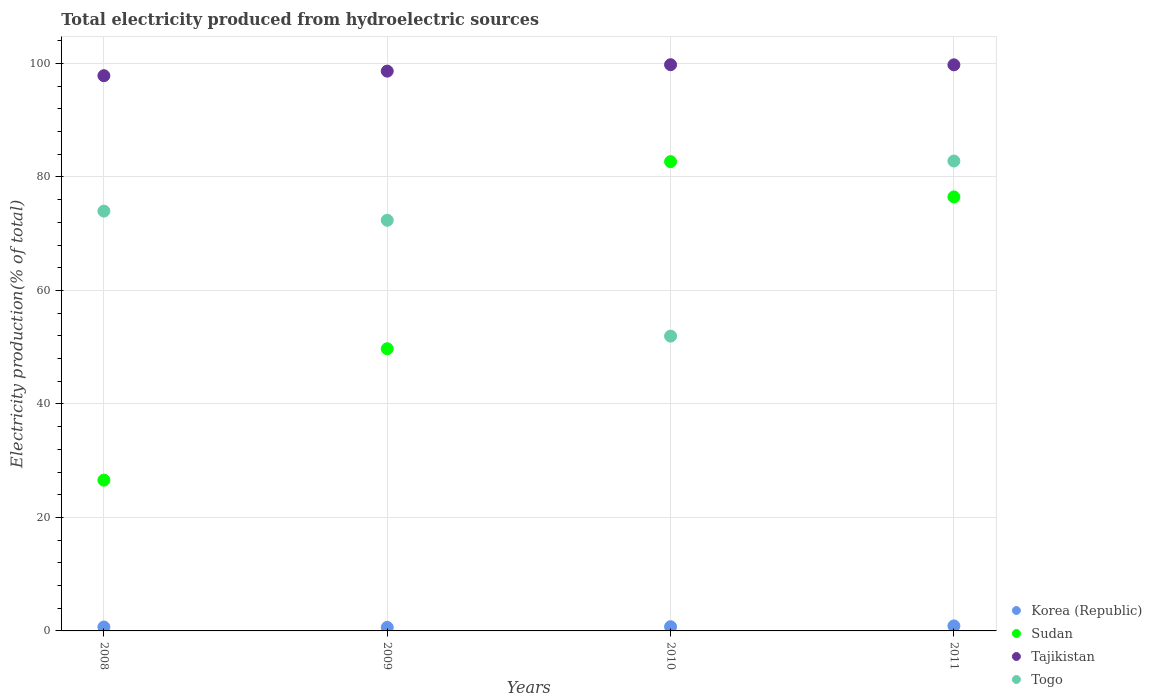What is the total electricity produced in Tajikistan in 2009?
Keep it short and to the point. 98.65. Across all years, what is the maximum total electricity produced in Sudan?
Offer a very short reply. 82.7. Across all years, what is the minimum total electricity produced in Tajikistan?
Keep it short and to the point. 97.85. In which year was the total electricity produced in Tajikistan maximum?
Provide a succinct answer. 2010. What is the total total electricity produced in Sudan in the graph?
Your answer should be very brief. 235.49. What is the difference between the total electricity produced in Togo in 2010 and that in 2011?
Ensure brevity in your answer.  -30.86. What is the difference between the total electricity produced in Korea (Republic) in 2009 and the total electricity produced in Sudan in 2010?
Offer a very short reply. -82.08. What is the average total electricity produced in Sudan per year?
Your answer should be very brief. 58.87. In the year 2011, what is the difference between the total electricity produced in Korea (Republic) and total electricity produced in Tajikistan?
Offer a very short reply. -98.88. What is the ratio of the total electricity produced in Sudan in 2008 to that in 2011?
Make the answer very short. 0.35. Is the difference between the total electricity produced in Korea (Republic) in 2008 and 2009 greater than the difference between the total electricity produced in Tajikistan in 2008 and 2009?
Provide a succinct answer. Yes. What is the difference between the highest and the second highest total electricity produced in Tajikistan?
Your answer should be compact. 0.02. What is the difference between the highest and the lowest total electricity produced in Sudan?
Offer a very short reply. 56.13. Is the sum of the total electricity produced in Korea (Republic) in 2008 and 2010 greater than the maximum total electricity produced in Sudan across all years?
Offer a terse response. No. Is it the case that in every year, the sum of the total electricity produced in Togo and total electricity produced in Sudan  is greater than the sum of total electricity produced in Korea (Republic) and total electricity produced in Tajikistan?
Your response must be concise. No. Is the total electricity produced in Korea (Republic) strictly less than the total electricity produced in Sudan over the years?
Make the answer very short. Yes. How many years are there in the graph?
Give a very brief answer. 4. Does the graph contain any zero values?
Ensure brevity in your answer.  No. Where does the legend appear in the graph?
Provide a succinct answer. Bottom right. How many legend labels are there?
Your response must be concise. 4. What is the title of the graph?
Give a very brief answer. Total electricity produced from hydroelectric sources. What is the Electricity production(% of total) in Korea (Republic) in 2008?
Offer a very short reply. 0.69. What is the Electricity production(% of total) in Sudan in 2008?
Keep it short and to the point. 26.57. What is the Electricity production(% of total) of Tajikistan in 2008?
Ensure brevity in your answer.  97.85. What is the Electricity production(% of total) in Togo in 2008?
Your answer should be compact. 73.98. What is the Electricity production(% of total) of Korea (Republic) in 2009?
Give a very brief answer. 0.62. What is the Electricity production(% of total) of Sudan in 2009?
Your answer should be compact. 49.73. What is the Electricity production(% of total) of Tajikistan in 2009?
Make the answer very short. 98.65. What is the Electricity production(% of total) in Togo in 2009?
Your response must be concise. 72.37. What is the Electricity production(% of total) in Korea (Republic) in 2010?
Your response must be concise. 0.74. What is the Electricity production(% of total) of Sudan in 2010?
Provide a short and direct response. 82.7. What is the Electricity production(% of total) in Tajikistan in 2010?
Your answer should be very brief. 99.79. What is the Electricity production(% of total) of Togo in 2010?
Keep it short and to the point. 51.96. What is the Electricity production(% of total) of Korea (Republic) in 2011?
Give a very brief answer. 0.88. What is the Electricity production(% of total) in Sudan in 2011?
Provide a succinct answer. 76.49. What is the Electricity production(% of total) of Tajikistan in 2011?
Your answer should be very brief. 99.77. What is the Electricity production(% of total) in Togo in 2011?
Provide a short and direct response. 82.81. Across all years, what is the maximum Electricity production(% of total) of Korea (Republic)?
Make the answer very short. 0.88. Across all years, what is the maximum Electricity production(% of total) of Sudan?
Keep it short and to the point. 82.7. Across all years, what is the maximum Electricity production(% of total) of Tajikistan?
Your answer should be compact. 99.79. Across all years, what is the maximum Electricity production(% of total) in Togo?
Your answer should be compact. 82.81. Across all years, what is the minimum Electricity production(% of total) in Korea (Republic)?
Ensure brevity in your answer.  0.62. Across all years, what is the minimum Electricity production(% of total) of Sudan?
Give a very brief answer. 26.57. Across all years, what is the minimum Electricity production(% of total) of Tajikistan?
Your answer should be compact. 97.85. Across all years, what is the minimum Electricity production(% of total) of Togo?
Ensure brevity in your answer.  51.96. What is the total Electricity production(% of total) of Korea (Republic) in the graph?
Your response must be concise. 2.94. What is the total Electricity production(% of total) in Sudan in the graph?
Offer a very short reply. 235.49. What is the total Electricity production(% of total) of Tajikistan in the graph?
Give a very brief answer. 396.06. What is the total Electricity production(% of total) of Togo in the graph?
Provide a succinct answer. 281.12. What is the difference between the Electricity production(% of total) in Korea (Republic) in 2008 and that in 2009?
Provide a short and direct response. 0.07. What is the difference between the Electricity production(% of total) in Sudan in 2008 and that in 2009?
Provide a short and direct response. -23.16. What is the difference between the Electricity production(% of total) in Tajikistan in 2008 and that in 2009?
Offer a very short reply. -0.8. What is the difference between the Electricity production(% of total) of Togo in 2008 and that in 2009?
Give a very brief answer. 1.62. What is the difference between the Electricity production(% of total) in Korea (Republic) in 2008 and that in 2010?
Your answer should be very brief. -0.05. What is the difference between the Electricity production(% of total) in Sudan in 2008 and that in 2010?
Keep it short and to the point. -56.13. What is the difference between the Electricity production(% of total) of Tajikistan in 2008 and that in 2010?
Offer a very short reply. -1.94. What is the difference between the Electricity production(% of total) of Togo in 2008 and that in 2010?
Your answer should be very brief. 22.03. What is the difference between the Electricity production(% of total) in Korea (Republic) in 2008 and that in 2011?
Offer a very short reply. -0.19. What is the difference between the Electricity production(% of total) of Sudan in 2008 and that in 2011?
Make the answer very short. -49.92. What is the difference between the Electricity production(% of total) of Tajikistan in 2008 and that in 2011?
Offer a terse response. -1.92. What is the difference between the Electricity production(% of total) of Togo in 2008 and that in 2011?
Keep it short and to the point. -8.83. What is the difference between the Electricity production(% of total) in Korea (Republic) in 2009 and that in 2010?
Your response must be concise. -0.12. What is the difference between the Electricity production(% of total) in Sudan in 2009 and that in 2010?
Make the answer very short. -32.97. What is the difference between the Electricity production(% of total) in Tajikistan in 2009 and that in 2010?
Your response must be concise. -1.13. What is the difference between the Electricity production(% of total) of Togo in 2009 and that in 2010?
Provide a short and direct response. 20.41. What is the difference between the Electricity production(% of total) in Korea (Republic) in 2009 and that in 2011?
Ensure brevity in your answer.  -0.26. What is the difference between the Electricity production(% of total) in Sudan in 2009 and that in 2011?
Your response must be concise. -26.76. What is the difference between the Electricity production(% of total) in Tajikistan in 2009 and that in 2011?
Provide a short and direct response. -1.11. What is the difference between the Electricity production(% of total) of Togo in 2009 and that in 2011?
Your answer should be compact. -10.44. What is the difference between the Electricity production(% of total) in Korea (Republic) in 2010 and that in 2011?
Your answer should be very brief. -0.14. What is the difference between the Electricity production(% of total) of Sudan in 2010 and that in 2011?
Your answer should be very brief. 6.22. What is the difference between the Electricity production(% of total) in Tajikistan in 2010 and that in 2011?
Your response must be concise. 0.02. What is the difference between the Electricity production(% of total) in Togo in 2010 and that in 2011?
Offer a very short reply. -30.86. What is the difference between the Electricity production(% of total) in Korea (Republic) in 2008 and the Electricity production(% of total) in Sudan in 2009?
Your answer should be very brief. -49.04. What is the difference between the Electricity production(% of total) of Korea (Republic) in 2008 and the Electricity production(% of total) of Tajikistan in 2009?
Ensure brevity in your answer.  -97.96. What is the difference between the Electricity production(% of total) in Korea (Republic) in 2008 and the Electricity production(% of total) in Togo in 2009?
Your response must be concise. -71.68. What is the difference between the Electricity production(% of total) in Sudan in 2008 and the Electricity production(% of total) in Tajikistan in 2009?
Your answer should be compact. -72.08. What is the difference between the Electricity production(% of total) in Sudan in 2008 and the Electricity production(% of total) in Togo in 2009?
Provide a short and direct response. -45.8. What is the difference between the Electricity production(% of total) in Tajikistan in 2008 and the Electricity production(% of total) in Togo in 2009?
Your answer should be very brief. 25.48. What is the difference between the Electricity production(% of total) in Korea (Republic) in 2008 and the Electricity production(% of total) in Sudan in 2010?
Offer a very short reply. -82.01. What is the difference between the Electricity production(% of total) in Korea (Republic) in 2008 and the Electricity production(% of total) in Tajikistan in 2010?
Your answer should be compact. -99.1. What is the difference between the Electricity production(% of total) of Korea (Republic) in 2008 and the Electricity production(% of total) of Togo in 2010?
Make the answer very short. -51.26. What is the difference between the Electricity production(% of total) in Sudan in 2008 and the Electricity production(% of total) in Tajikistan in 2010?
Provide a succinct answer. -73.22. What is the difference between the Electricity production(% of total) in Sudan in 2008 and the Electricity production(% of total) in Togo in 2010?
Provide a succinct answer. -25.38. What is the difference between the Electricity production(% of total) of Tajikistan in 2008 and the Electricity production(% of total) of Togo in 2010?
Offer a very short reply. 45.9. What is the difference between the Electricity production(% of total) of Korea (Republic) in 2008 and the Electricity production(% of total) of Sudan in 2011?
Your answer should be compact. -75.8. What is the difference between the Electricity production(% of total) of Korea (Republic) in 2008 and the Electricity production(% of total) of Tajikistan in 2011?
Provide a succinct answer. -99.07. What is the difference between the Electricity production(% of total) in Korea (Republic) in 2008 and the Electricity production(% of total) in Togo in 2011?
Your response must be concise. -82.12. What is the difference between the Electricity production(% of total) in Sudan in 2008 and the Electricity production(% of total) in Tajikistan in 2011?
Your response must be concise. -73.19. What is the difference between the Electricity production(% of total) of Sudan in 2008 and the Electricity production(% of total) of Togo in 2011?
Offer a terse response. -56.24. What is the difference between the Electricity production(% of total) of Tajikistan in 2008 and the Electricity production(% of total) of Togo in 2011?
Your answer should be compact. 15.04. What is the difference between the Electricity production(% of total) in Korea (Republic) in 2009 and the Electricity production(% of total) in Sudan in 2010?
Provide a succinct answer. -82.08. What is the difference between the Electricity production(% of total) in Korea (Republic) in 2009 and the Electricity production(% of total) in Tajikistan in 2010?
Provide a succinct answer. -99.16. What is the difference between the Electricity production(% of total) in Korea (Republic) in 2009 and the Electricity production(% of total) in Togo in 2010?
Your answer should be compact. -51.33. What is the difference between the Electricity production(% of total) of Sudan in 2009 and the Electricity production(% of total) of Tajikistan in 2010?
Keep it short and to the point. -50.06. What is the difference between the Electricity production(% of total) of Sudan in 2009 and the Electricity production(% of total) of Togo in 2010?
Keep it short and to the point. -2.22. What is the difference between the Electricity production(% of total) of Tajikistan in 2009 and the Electricity production(% of total) of Togo in 2010?
Your answer should be compact. 46.7. What is the difference between the Electricity production(% of total) of Korea (Republic) in 2009 and the Electricity production(% of total) of Sudan in 2011?
Make the answer very short. -75.86. What is the difference between the Electricity production(% of total) of Korea (Republic) in 2009 and the Electricity production(% of total) of Tajikistan in 2011?
Give a very brief answer. -99.14. What is the difference between the Electricity production(% of total) in Korea (Republic) in 2009 and the Electricity production(% of total) in Togo in 2011?
Keep it short and to the point. -82.19. What is the difference between the Electricity production(% of total) in Sudan in 2009 and the Electricity production(% of total) in Tajikistan in 2011?
Your response must be concise. -50.04. What is the difference between the Electricity production(% of total) of Sudan in 2009 and the Electricity production(% of total) of Togo in 2011?
Offer a terse response. -33.08. What is the difference between the Electricity production(% of total) of Tajikistan in 2009 and the Electricity production(% of total) of Togo in 2011?
Give a very brief answer. 15.84. What is the difference between the Electricity production(% of total) of Korea (Republic) in 2010 and the Electricity production(% of total) of Sudan in 2011?
Ensure brevity in your answer.  -75.75. What is the difference between the Electricity production(% of total) in Korea (Republic) in 2010 and the Electricity production(% of total) in Tajikistan in 2011?
Keep it short and to the point. -99.02. What is the difference between the Electricity production(% of total) in Korea (Republic) in 2010 and the Electricity production(% of total) in Togo in 2011?
Your response must be concise. -82.07. What is the difference between the Electricity production(% of total) of Sudan in 2010 and the Electricity production(% of total) of Tajikistan in 2011?
Offer a terse response. -17.06. What is the difference between the Electricity production(% of total) in Sudan in 2010 and the Electricity production(% of total) in Togo in 2011?
Offer a very short reply. -0.11. What is the difference between the Electricity production(% of total) of Tajikistan in 2010 and the Electricity production(% of total) of Togo in 2011?
Your answer should be very brief. 16.97. What is the average Electricity production(% of total) of Korea (Republic) per year?
Offer a very short reply. 0.73. What is the average Electricity production(% of total) in Sudan per year?
Offer a very short reply. 58.87. What is the average Electricity production(% of total) in Tajikistan per year?
Ensure brevity in your answer.  99.01. What is the average Electricity production(% of total) in Togo per year?
Provide a short and direct response. 70.28. In the year 2008, what is the difference between the Electricity production(% of total) in Korea (Republic) and Electricity production(% of total) in Sudan?
Make the answer very short. -25.88. In the year 2008, what is the difference between the Electricity production(% of total) in Korea (Republic) and Electricity production(% of total) in Tajikistan?
Your answer should be compact. -97.16. In the year 2008, what is the difference between the Electricity production(% of total) of Korea (Republic) and Electricity production(% of total) of Togo?
Ensure brevity in your answer.  -73.29. In the year 2008, what is the difference between the Electricity production(% of total) in Sudan and Electricity production(% of total) in Tajikistan?
Provide a succinct answer. -71.28. In the year 2008, what is the difference between the Electricity production(% of total) of Sudan and Electricity production(% of total) of Togo?
Your answer should be compact. -47.41. In the year 2008, what is the difference between the Electricity production(% of total) in Tajikistan and Electricity production(% of total) in Togo?
Your answer should be compact. 23.87. In the year 2009, what is the difference between the Electricity production(% of total) in Korea (Republic) and Electricity production(% of total) in Sudan?
Give a very brief answer. -49.11. In the year 2009, what is the difference between the Electricity production(% of total) of Korea (Republic) and Electricity production(% of total) of Tajikistan?
Offer a terse response. -98.03. In the year 2009, what is the difference between the Electricity production(% of total) of Korea (Republic) and Electricity production(% of total) of Togo?
Provide a succinct answer. -71.75. In the year 2009, what is the difference between the Electricity production(% of total) of Sudan and Electricity production(% of total) of Tajikistan?
Provide a short and direct response. -48.92. In the year 2009, what is the difference between the Electricity production(% of total) in Sudan and Electricity production(% of total) in Togo?
Ensure brevity in your answer.  -22.64. In the year 2009, what is the difference between the Electricity production(% of total) in Tajikistan and Electricity production(% of total) in Togo?
Your response must be concise. 26.29. In the year 2010, what is the difference between the Electricity production(% of total) in Korea (Republic) and Electricity production(% of total) in Sudan?
Make the answer very short. -81.96. In the year 2010, what is the difference between the Electricity production(% of total) of Korea (Republic) and Electricity production(% of total) of Tajikistan?
Offer a terse response. -99.05. In the year 2010, what is the difference between the Electricity production(% of total) of Korea (Republic) and Electricity production(% of total) of Togo?
Offer a terse response. -51.21. In the year 2010, what is the difference between the Electricity production(% of total) in Sudan and Electricity production(% of total) in Tajikistan?
Keep it short and to the point. -17.08. In the year 2010, what is the difference between the Electricity production(% of total) of Sudan and Electricity production(% of total) of Togo?
Keep it short and to the point. 30.75. In the year 2010, what is the difference between the Electricity production(% of total) in Tajikistan and Electricity production(% of total) in Togo?
Your answer should be compact. 47.83. In the year 2011, what is the difference between the Electricity production(% of total) in Korea (Republic) and Electricity production(% of total) in Sudan?
Keep it short and to the point. -75.6. In the year 2011, what is the difference between the Electricity production(% of total) in Korea (Republic) and Electricity production(% of total) in Tajikistan?
Keep it short and to the point. -98.88. In the year 2011, what is the difference between the Electricity production(% of total) in Korea (Republic) and Electricity production(% of total) in Togo?
Offer a terse response. -81.93. In the year 2011, what is the difference between the Electricity production(% of total) of Sudan and Electricity production(% of total) of Tajikistan?
Keep it short and to the point. -23.28. In the year 2011, what is the difference between the Electricity production(% of total) of Sudan and Electricity production(% of total) of Togo?
Provide a short and direct response. -6.33. In the year 2011, what is the difference between the Electricity production(% of total) in Tajikistan and Electricity production(% of total) in Togo?
Offer a very short reply. 16.95. What is the ratio of the Electricity production(% of total) of Korea (Republic) in 2008 to that in 2009?
Your answer should be compact. 1.11. What is the ratio of the Electricity production(% of total) in Sudan in 2008 to that in 2009?
Provide a succinct answer. 0.53. What is the ratio of the Electricity production(% of total) of Togo in 2008 to that in 2009?
Ensure brevity in your answer.  1.02. What is the ratio of the Electricity production(% of total) of Korea (Republic) in 2008 to that in 2010?
Provide a short and direct response. 0.93. What is the ratio of the Electricity production(% of total) of Sudan in 2008 to that in 2010?
Your answer should be compact. 0.32. What is the ratio of the Electricity production(% of total) in Tajikistan in 2008 to that in 2010?
Provide a short and direct response. 0.98. What is the ratio of the Electricity production(% of total) of Togo in 2008 to that in 2010?
Provide a succinct answer. 1.42. What is the ratio of the Electricity production(% of total) in Korea (Republic) in 2008 to that in 2011?
Provide a succinct answer. 0.78. What is the ratio of the Electricity production(% of total) in Sudan in 2008 to that in 2011?
Give a very brief answer. 0.35. What is the ratio of the Electricity production(% of total) in Tajikistan in 2008 to that in 2011?
Provide a short and direct response. 0.98. What is the ratio of the Electricity production(% of total) of Togo in 2008 to that in 2011?
Make the answer very short. 0.89. What is the ratio of the Electricity production(% of total) in Korea (Republic) in 2009 to that in 2010?
Your answer should be very brief. 0.84. What is the ratio of the Electricity production(% of total) in Sudan in 2009 to that in 2010?
Your response must be concise. 0.6. What is the ratio of the Electricity production(% of total) of Tajikistan in 2009 to that in 2010?
Your answer should be compact. 0.99. What is the ratio of the Electricity production(% of total) of Togo in 2009 to that in 2010?
Offer a very short reply. 1.39. What is the ratio of the Electricity production(% of total) in Korea (Republic) in 2009 to that in 2011?
Offer a terse response. 0.7. What is the ratio of the Electricity production(% of total) in Sudan in 2009 to that in 2011?
Keep it short and to the point. 0.65. What is the ratio of the Electricity production(% of total) of Tajikistan in 2009 to that in 2011?
Keep it short and to the point. 0.99. What is the ratio of the Electricity production(% of total) of Togo in 2009 to that in 2011?
Offer a very short reply. 0.87. What is the ratio of the Electricity production(% of total) in Korea (Republic) in 2010 to that in 2011?
Your answer should be compact. 0.84. What is the ratio of the Electricity production(% of total) in Sudan in 2010 to that in 2011?
Keep it short and to the point. 1.08. What is the ratio of the Electricity production(% of total) in Togo in 2010 to that in 2011?
Ensure brevity in your answer.  0.63. What is the difference between the highest and the second highest Electricity production(% of total) of Korea (Republic)?
Keep it short and to the point. 0.14. What is the difference between the highest and the second highest Electricity production(% of total) of Sudan?
Provide a short and direct response. 6.22. What is the difference between the highest and the second highest Electricity production(% of total) in Tajikistan?
Offer a very short reply. 0.02. What is the difference between the highest and the second highest Electricity production(% of total) in Togo?
Your answer should be very brief. 8.83. What is the difference between the highest and the lowest Electricity production(% of total) of Korea (Republic)?
Your answer should be compact. 0.26. What is the difference between the highest and the lowest Electricity production(% of total) of Sudan?
Provide a succinct answer. 56.13. What is the difference between the highest and the lowest Electricity production(% of total) of Tajikistan?
Offer a very short reply. 1.94. What is the difference between the highest and the lowest Electricity production(% of total) in Togo?
Your answer should be very brief. 30.86. 